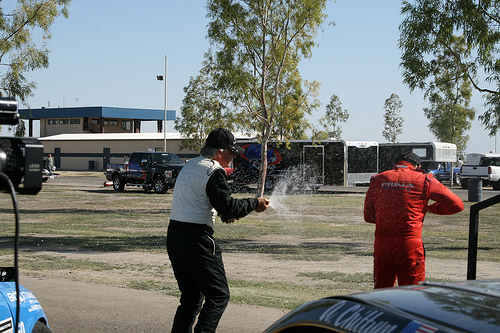<image>
Is there a building behind the tree? Yes. From this viewpoint, the building is positioned behind the tree, with the tree partially or fully occluding the building. Is there a tree behind the man? No. The tree is not behind the man. From this viewpoint, the tree appears to be positioned elsewhere in the scene. Is the man behind the car? No. The man is not behind the car. From this viewpoint, the man appears to be positioned elsewhere in the scene. 